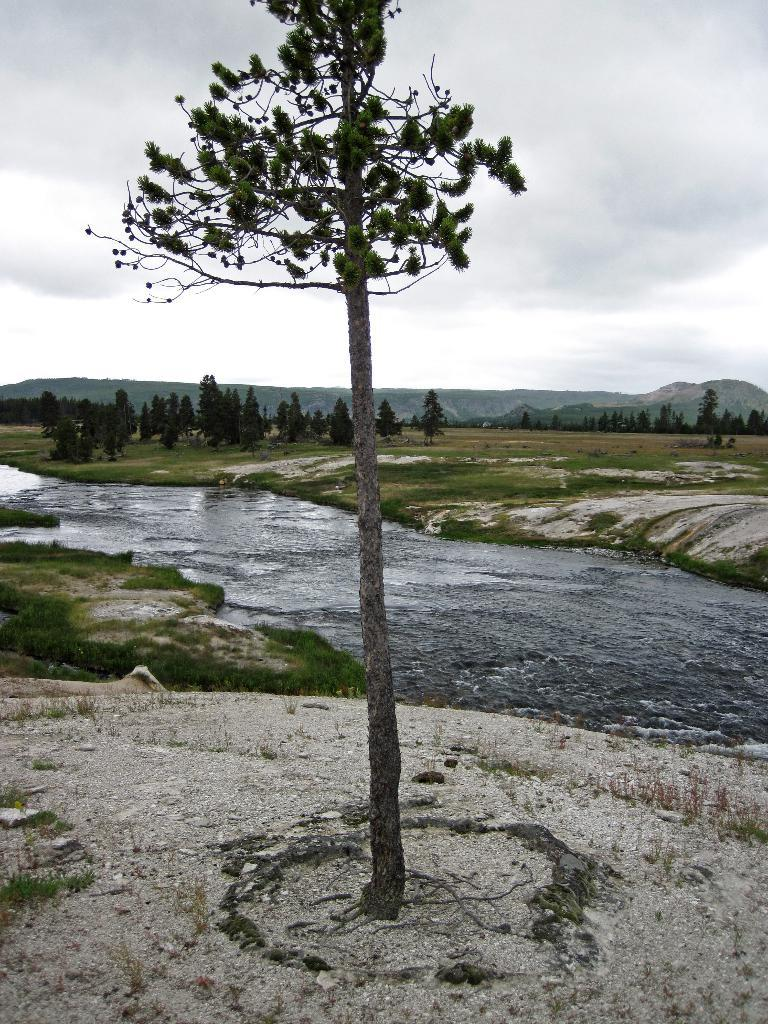What type of vegetation can be seen in the image? There is a tree and additional trees visible in the image. What is the ground surface like in the image? The ground has grass in the image. What natural feature can be seen in the image? There is a water flow in the image. What can be seen in the distance in the image? Mountains are visible in the background of the image. Where are the toys scattered in the image? There are no toys present in the image. What type of veil can be seen covering the tree in the image? There is no veil covering the tree in the image; the tree is visible without any covering. 